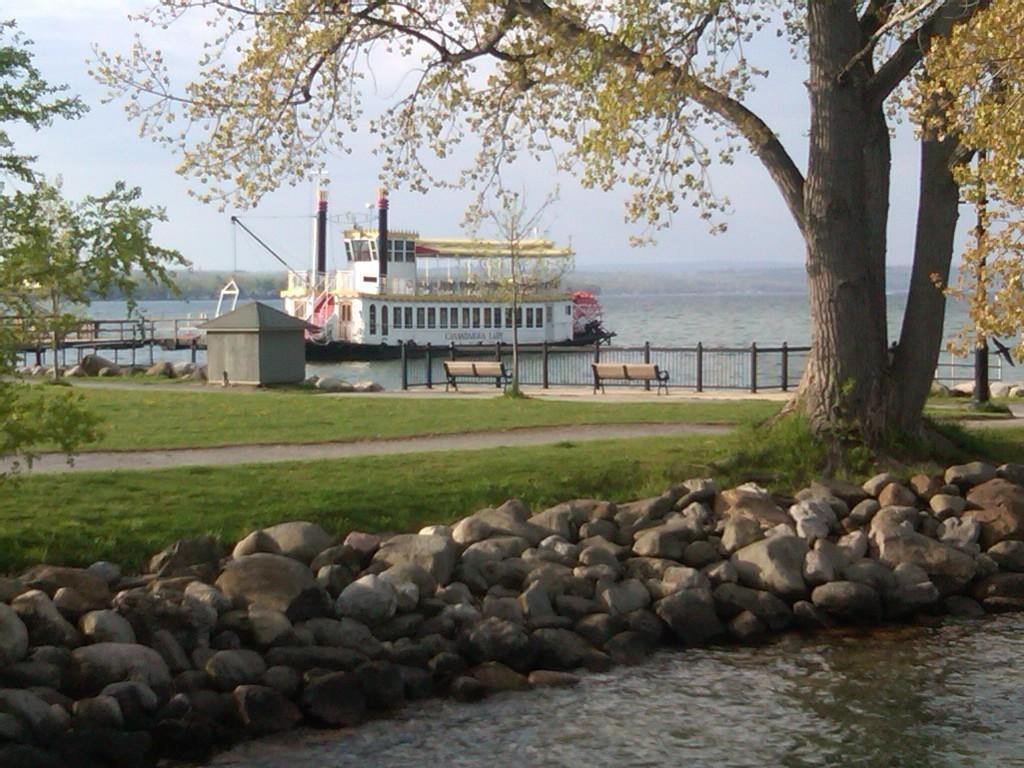In one or two sentences, can you explain what this image depicts? In this image we can see stones and water at the bottom. Also there are trees. On the ground there is grass. In the back we can see shed, stones, benches and railings. Also there is a ship on the water. In the background there is sky. 